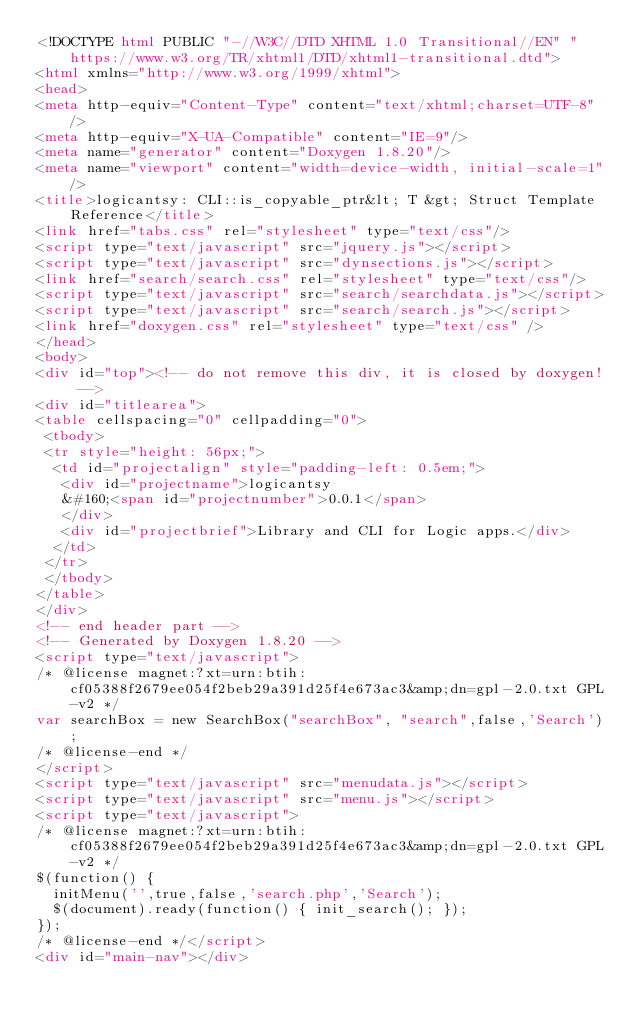<code> <loc_0><loc_0><loc_500><loc_500><_HTML_><!DOCTYPE html PUBLIC "-//W3C//DTD XHTML 1.0 Transitional//EN" "https://www.w3.org/TR/xhtml1/DTD/xhtml1-transitional.dtd">
<html xmlns="http://www.w3.org/1999/xhtml">
<head>
<meta http-equiv="Content-Type" content="text/xhtml;charset=UTF-8"/>
<meta http-equiv="X-UA-Compatible" content="IE=9"/>
<meta name="generator" content="Doxygen 1.8.20"/>
<meta name="viewport" content="width=device-width, initial-scale=1"/>
<title>logicantsy: CLI::is_copyable_ptr&lt; T &gt; Struct Template Reference</title>
<link href="tabs.css" rel="stylesheet" type="text/css"/>
<script type="text/javascript" src="jquery.js"></script>
<script type="text/javascript" src="dynsections.js"></script>
<link href="search/search.css" rel="stylesheet" type="text/css"/>
<script type="text/javascript" src="search/searchdata.js"></script>
<script type="text/javascript" src="search/search.js"></script>
<link href="doxygen.css" rel="stylesheet" type="text/css" />
</head>
<body>
<div id="top"><!-- do not remove this div, it is closed by doxygen! -->
<div id="titlearea">
<table cellspacing="0" cellpadding="0">
 <tbody>
 <tr style="height: 56px;">
  <td id="projectalign" style="padding-left: 0.5em;">
   <div id="projectname">logicantsy
   &#160;<span id="projectnumber">0.0.1</span>
   </div>
   <div id="projectbrief">Library and CLI for Logic apps.</div>
  </td>
 </tr>
 </tbody>
</table>
</div>
<!-- end header part -->
<!-- Generated by Doxygen 1.8.20 -->
<script type="text/javascript">
/* @license magnet:?xt=urn:btih:cf05388f2679ee054f2beb29a391d25f4e673ac3&amp;dn=gpl-2.0.txt GPL-v2 */
var searchBox = new SearchBox("searchBox", "search",false,'Search');
/* @license-end */
</script>
<script type="text/javascript" src="menudata.js"></script>
<script type="text/javascript" src="menu.js"></script>
<script type="text/javascript">
/* @license magnet:?xt=urn:btih:cf05388f2679ee054f2beb29a391d25f4e673ac3&amp;dn=gpl-2.0.txt GPL-v2 */
$(function() {
  initMenu('',true,false,'search.php','Search');
  $(document).ready(function() { init_search(); });
});
/* @license-end */</script>
<div id="main-nav"></div></code> 